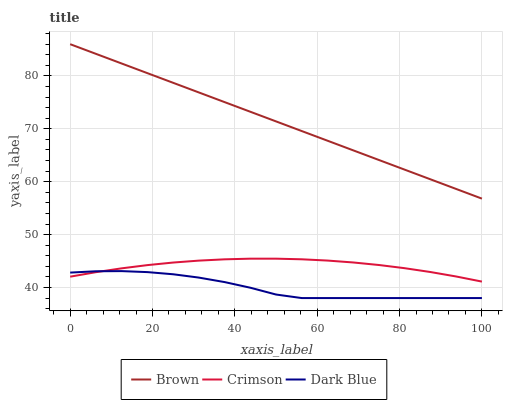Does Dark Blue have the minimum area under the curve?
Answer yes or no. Yes. Does Brown have the maximum area under the curve?
Answer yes or no. Yes. Does Brown have the minimum area under the curve?
Answer yes or no. No. Does Dark Blue have the maximum area under the curve?
Answer yes or no. No. Is Brown the smoothest?
Answer yes or no. Yes. Is Dark Blue the roughest?
Answer yes or no. Yes. Is Dark Blue the smoothest?
Answer yes or no. No. Is Brown the roughest?
Answer yes or no. No. Does Dark Blue have the lowest value?
Answer yes or no. Yes. Does Brown have the lowest value?
Answer yes or no. No. Does Brown have the highest value?
Answer yes or no. Yes. Does Dark Blue have the highest value?
Answer yes or no. No. Is Dark Blue less than Brown?
Answer yes or no. Yes. Is Brown greater than Dark Blue?
Answer yes or no. Yes. Does Dark Blue intersect Crimson?
Answer yes or no. Yes. Is Dark Blue less than Crimson?
Answer yes or no. No. Is Dark Blue greater than Crimson?
Answer yes or no. No. Does Dark Blue intersect Brown?
Answer yes or no. No. 